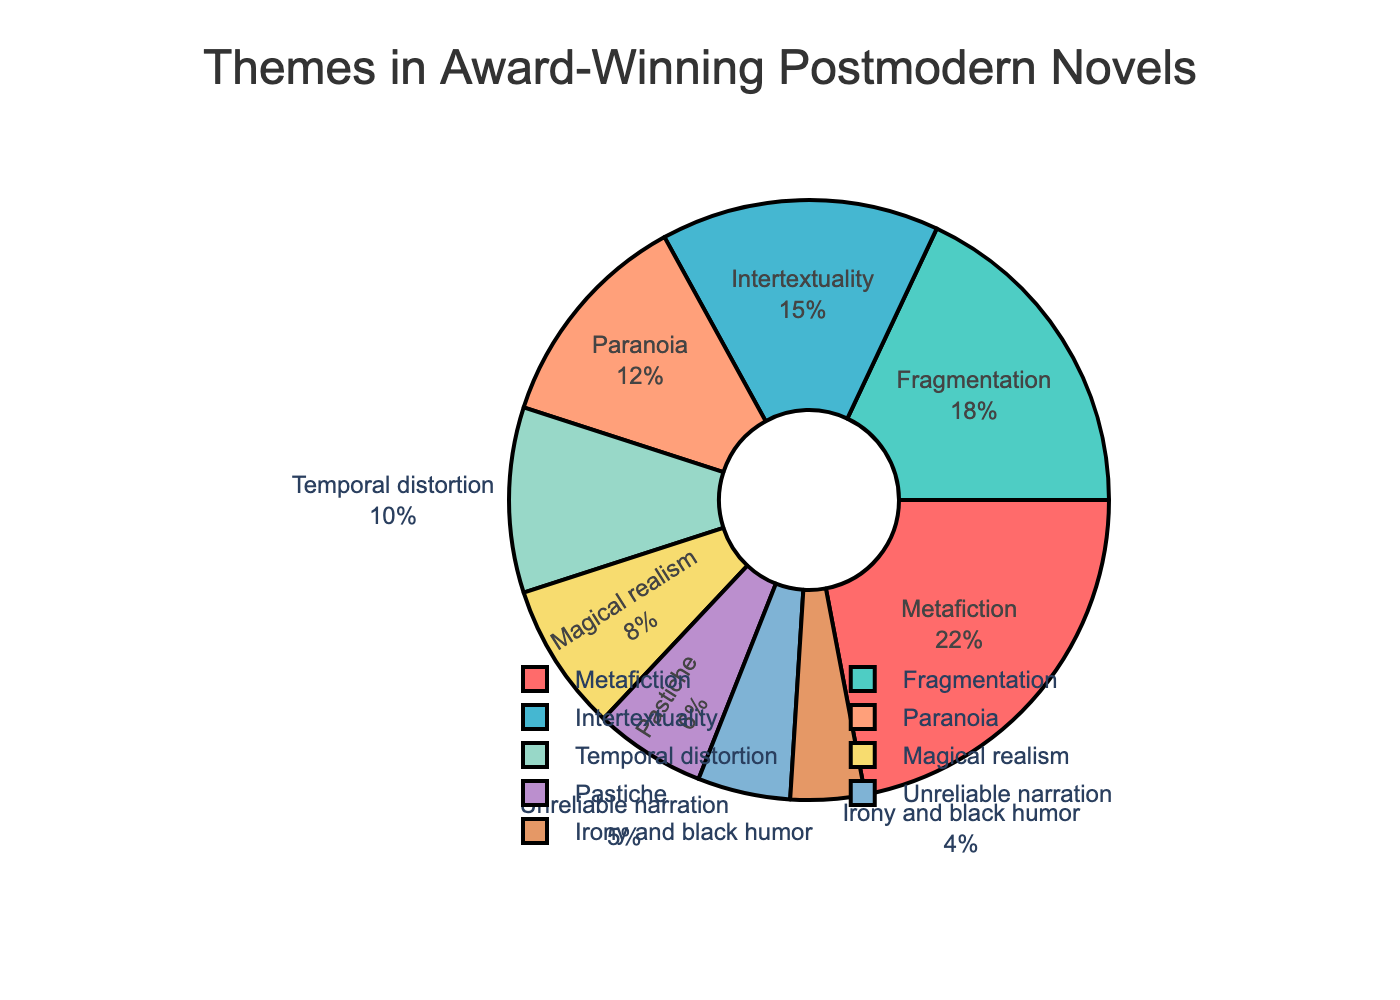Which theme is the most prevalent in the pie chart? The largest segment in the pie chart represents the most prevalent theme. The Metafiction segment, with 22%, is the largest, indicating it is the most prevalent theme.
Answer: Metafiction Which two themes together make up 30% of the total? Add up the percentages of different themes to find pairs that total 30%. Temporal distortion (10%) and Magical realism (8%) together with Unreliable narration (5%) and Irony and black humor (4%) sum to 27% and 29%, but Fragmentation (18%) and Unreliable narration (5%) add up to 23%. Therefore, Fragmentation (18%) and Intertextuality (15%) sum up to 33%, and Metafiction (22%) and Irony and black humor (4%) sum to 26%. So, Intertextuality (15%) and Paranoia (12%) add up to 27%, thus Pastiche (6%) and Unreliable narration (5%) sum up to 11%, none match to a pair adding to 30%.
Answer: No exact pair What is the ratio of the largest theme to the smallest theme? The largest theme is Metafiction with 22%, and the smallest theme is Irony and black humor with 4%. The ratio is calculated as 22/4.
Answer: 5.5 Which themes are represented by colors that are closest to red and orange? The Metafiction segment is colored red and the Temporal distortion segment is colored orange.
Answer: Metafiction, Temporal distortion How much more prevalent is Fragmentation than Pastiche? Subtract the percentage of Pastiche from Fragmentation. Fragmentation is 18% and Pastiche is 6%. The difference is 18% - 6%.
Answer: 12% Combine the percentages of themes with less than 10% representation. What is the total? Sum the percentages of the themes with less than 10% representation: Temporal distortion (10%), Magical realism (8%), Pastiche (6%), Unreliable narration (5%), Irony and black humor (4%).
Answer: 33% Which theme has the closest percentage to the sum of Magical realism and Unreliable narration? Add the percentages of Magical realism and Unreliable narration: 8% + 5% = 13%. Paranoia has 12%, which is closest to 13%.
Answer: Paranoia How many themes have a representation of more than 15%? Identify the themes with percentages greater than 15%. Metafiction is 22%, Fragmentation is 18%, Intertextuality is 15%. Only Metafiction and Fragmentation are more than 15%.
Answer: 2 Is there any theme that makes up exactly one-fifth of the pie chart? One-fifth of the pie chart is 20%. Metafiction makes up 22%, and no other theme matches exactly 20%.
Answer: No 